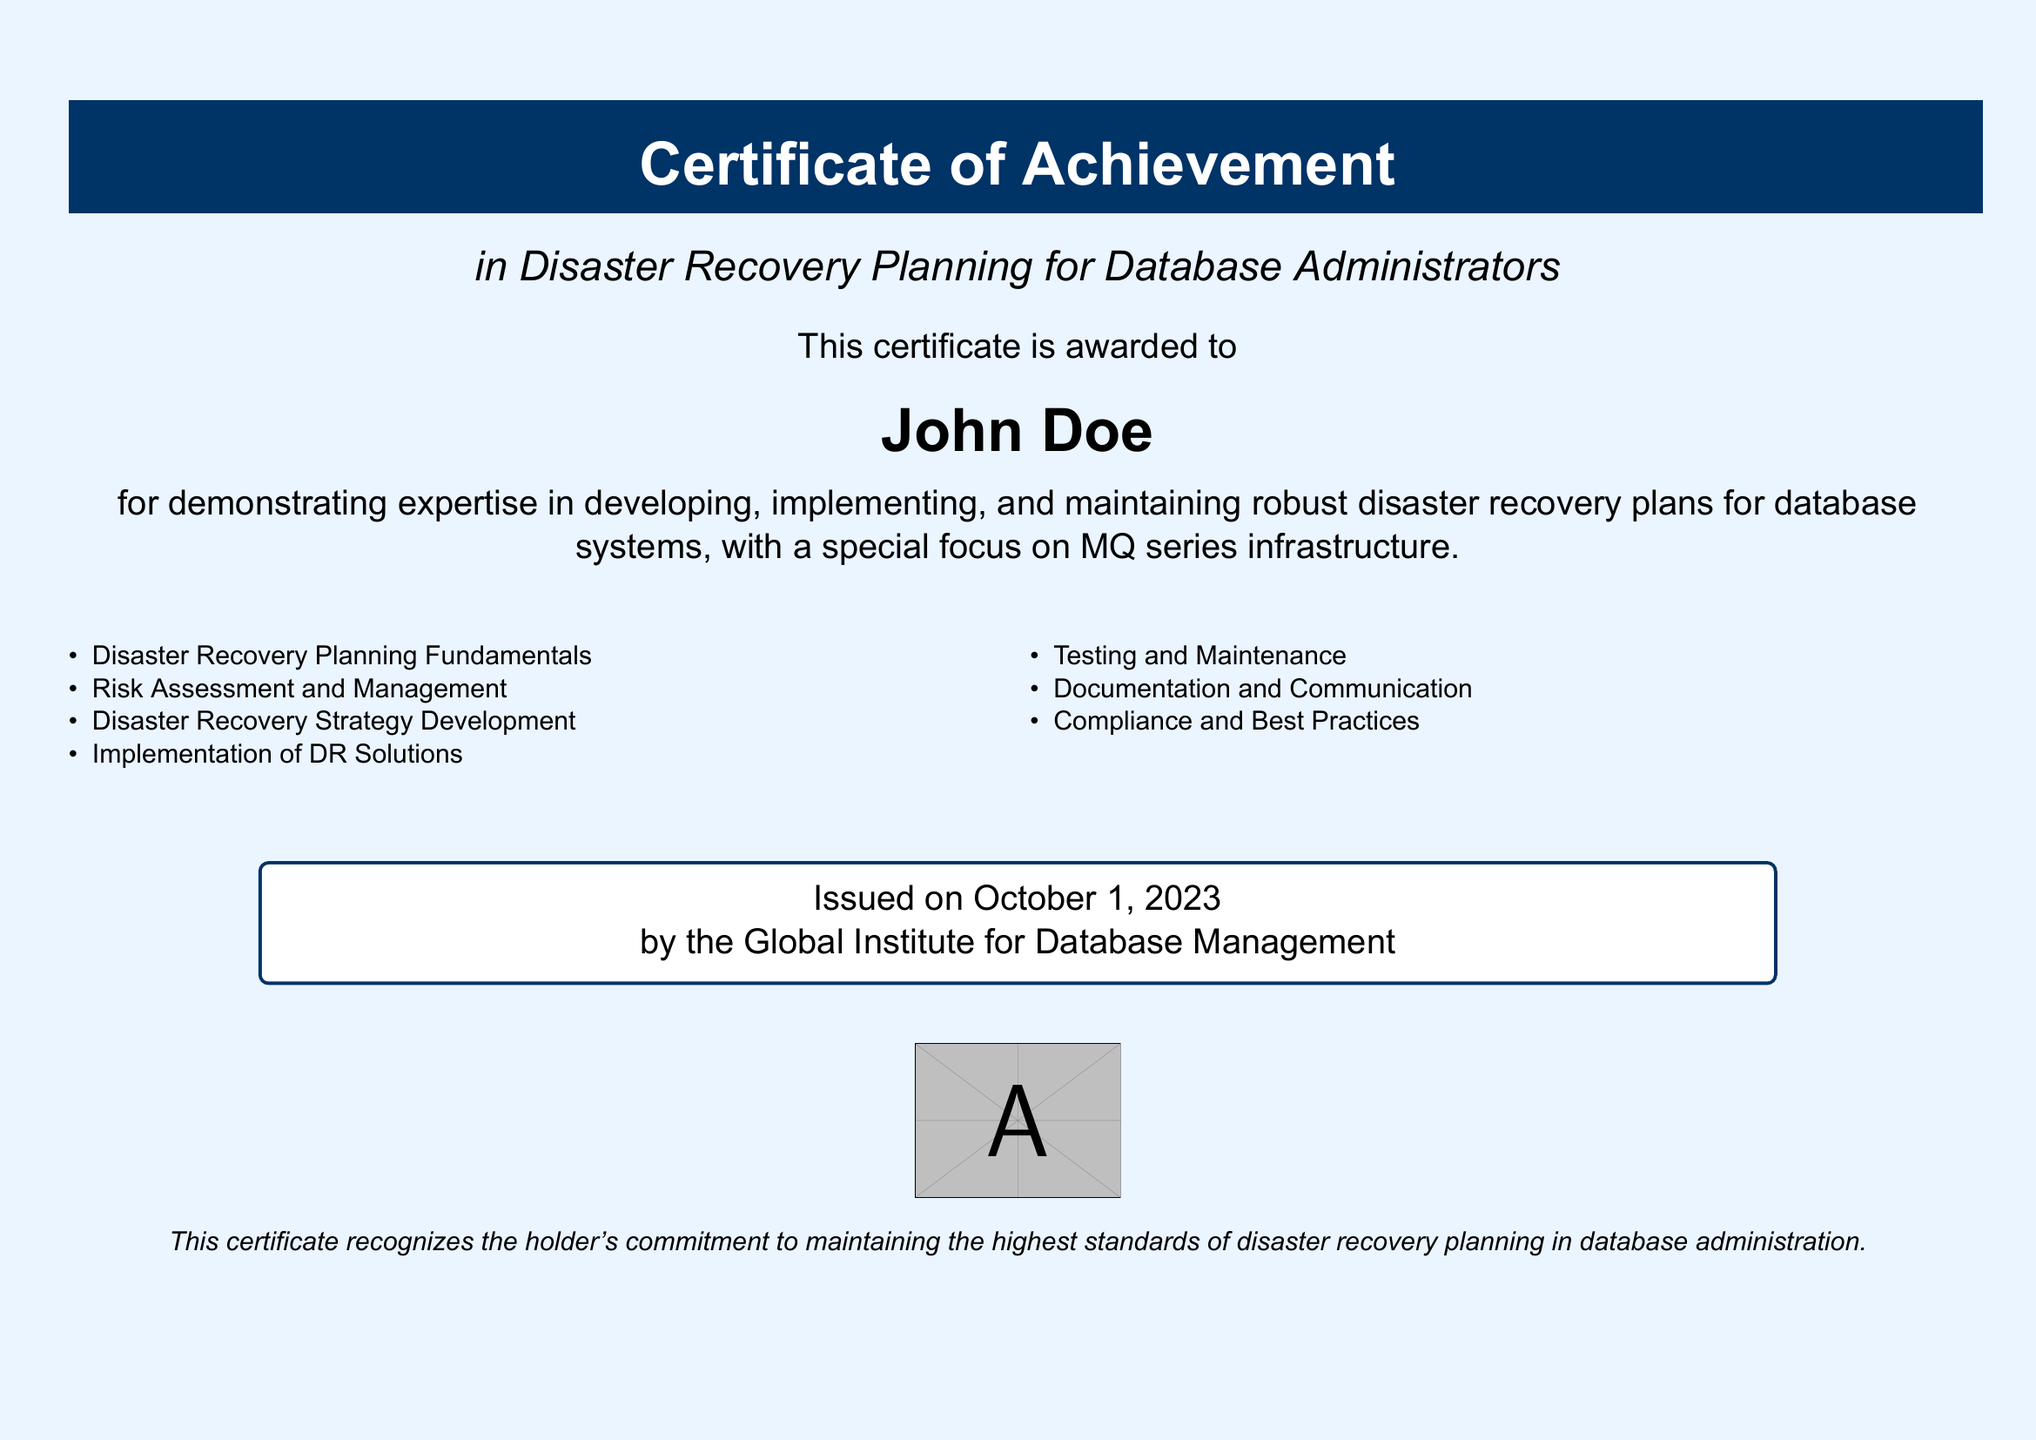What is the title of the certificate? The title of the certificate is "Certificate of Achievement".
Answer: Certificate of Achievement Who is the certificate awarded to? The name of the individual who received the certificate is specified in the document.
Answer: John Doe What date was the certificate issued? The document clearly states the date of issuance at the bottom.
Answer: October 1, 2023 What organization issued the certificate? The issuing organization is named at the end of the document.
Answer: Global Institute for Database Management Which subject area does this certificate focus on? The document specifies the focus area of the certificate.
Answer: Disaster Recovery Planning for Database Administrators What are the first two topics listed under competencies? The first two topics listed provide insight into the competencies covered by the course.
Answer: Disaster Recovery Planning Fundamentals, Risk Assessment and Management How many competencies are listed on the certificate? The total number of competencies can be counted from the itemized list in the document.
Answer: Seven What color is used for the certificate's background? The color of the background is mentioned in the document description.
Answer: Light blue What is the main purpose of this certificate? The document mentions the commitment recognized through this certificate.
Answer: Maintaining the highest standards of disaster recovery planning in database administration 